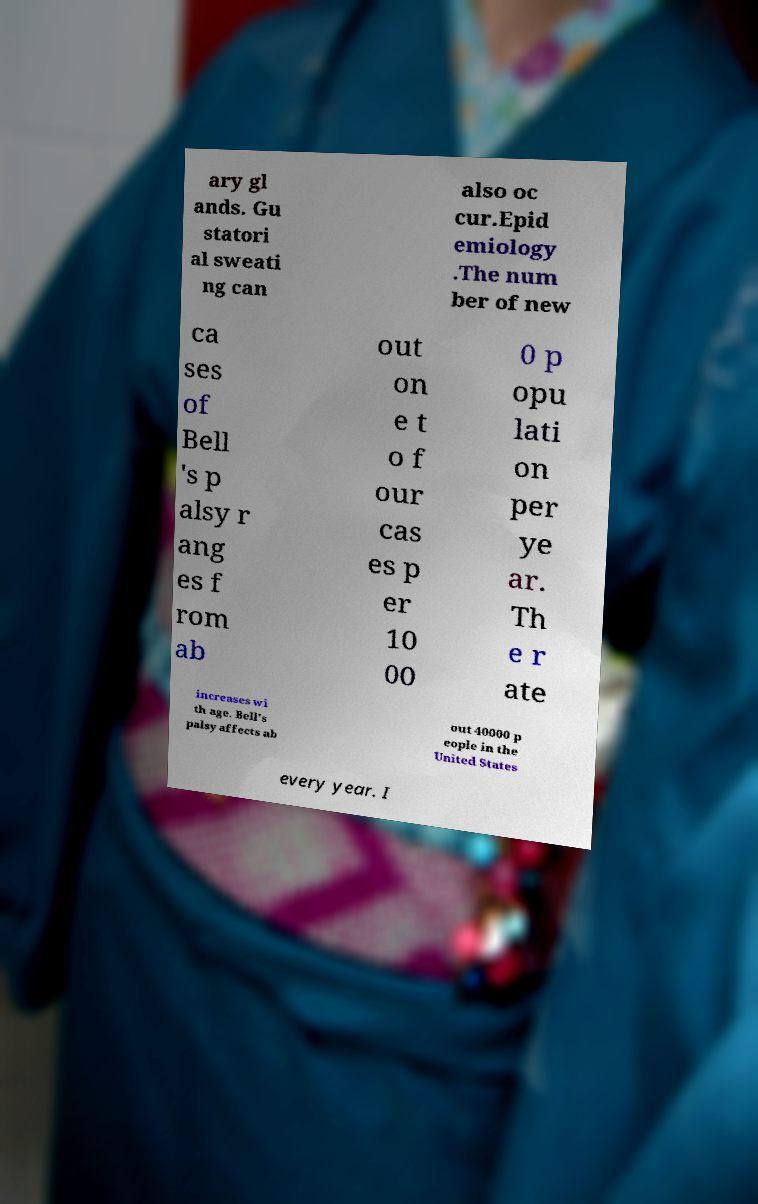Can you accurately transcribe the text from the provided image for me? ary gl ands. Gu statori al sweati ng can also oc cur.Epid emiology .The num ber of new ca ses of Bell 's p alsy r ang es f rom ab out on e t o f our cas es p er 10 00 0 p opu lati on per ye ar. Th e r ate increases wi th age. Bell's palsy affects ab out 40000 p eople in the United States every year. I 